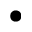<formula> <loc_0><loc_0><loc_500><loc_500>\bullet</formula> 